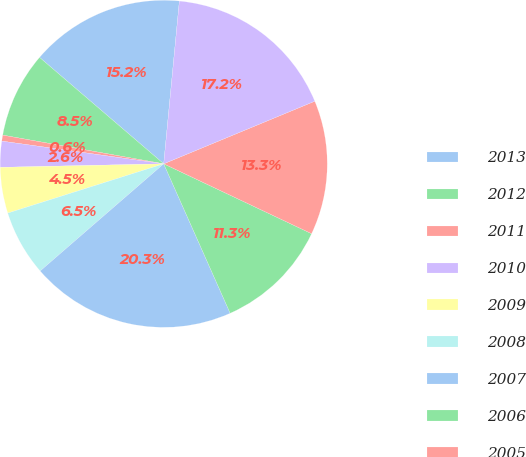Convert chart. <chart><loc_0><loc_0><loc_500><loc_500><pie_chart><fcel>2013<fcel>2012<fcel>2011<fcel>2010<fcel>2009<fcel>2008<fcel>2007<fcel>2006<fcel>2005<fcel>2004<nl><fcel>15.25%<fcel>8.47%<fcel>0.59%<fcel>2.56%<fcel>4.53%<fcel>6.5%<fcel>20.29%<fcel>11.31%<fcel>13.28%<fcel>17.22%<nl></chart> 